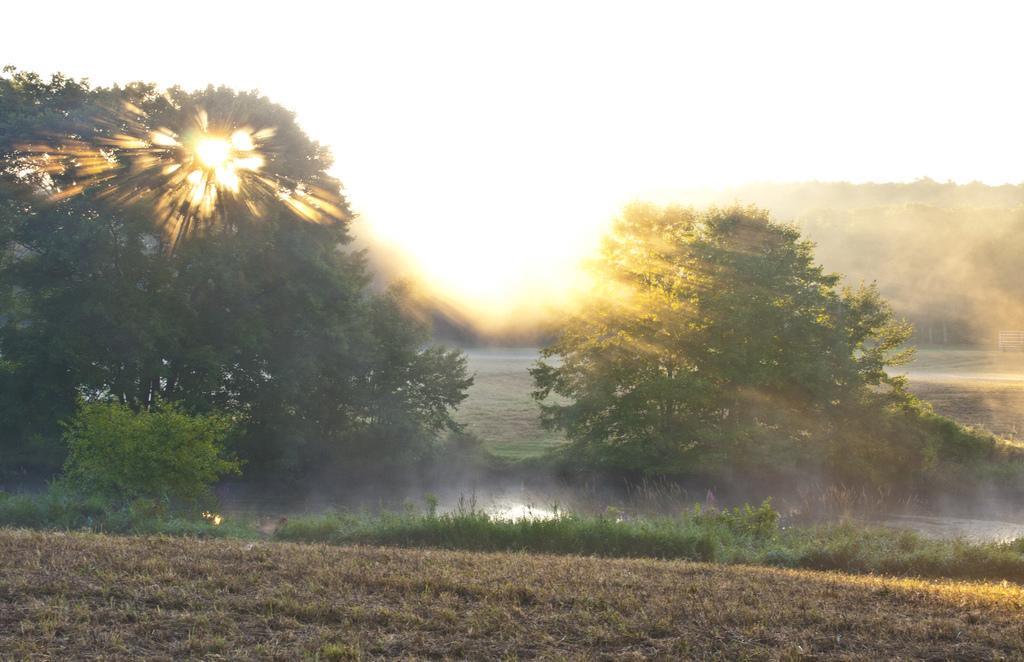What type of vegetation can be seen in the image? There are trees in the image. What is visible in the foreground of the image? There appears to be water in the foreground of the image. Can you describe the background of the image? There are trees and the sky visible in the background of the image. The sun is observable in the sky. What type of terrain is present at the bottom side of the image? There is dry grassland at the bottom side of the image. What type of trousers can be seen hanging on the trees in the image? There are no trousers present in the image; it features trees, water, and dry grassland. Is there a train visible in the image? No, there is no train present in the image. 